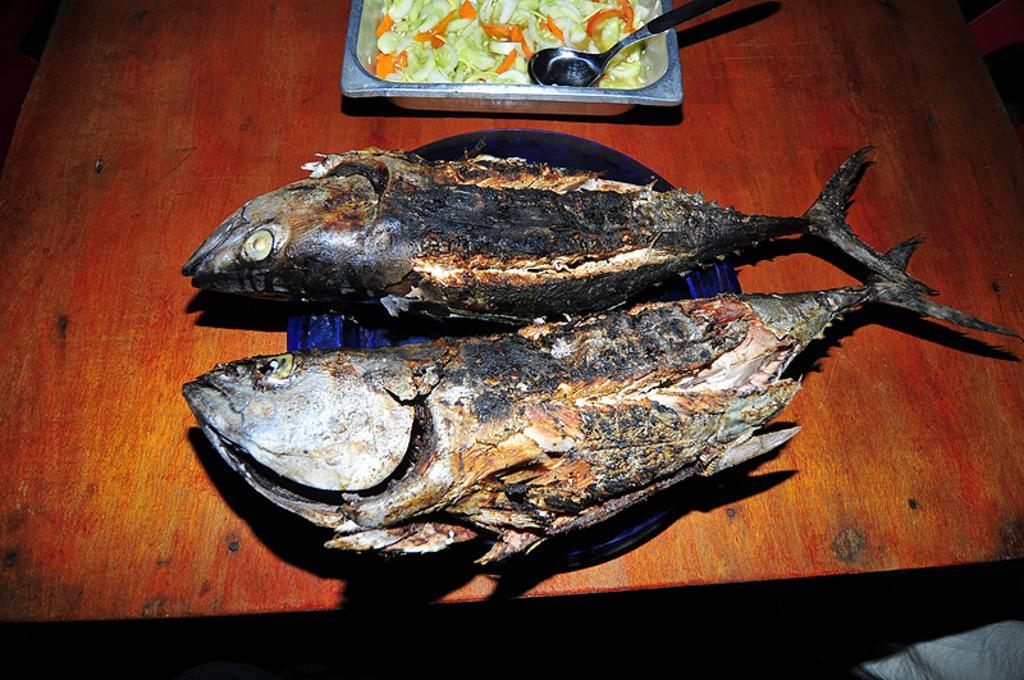Describe this image in one or two sentences. In this image I can see two fishes in the bowl and the bowl is in black color and the bowl is on the table. Background I can see the food which is in orange and green color and I can also see a spoon. 